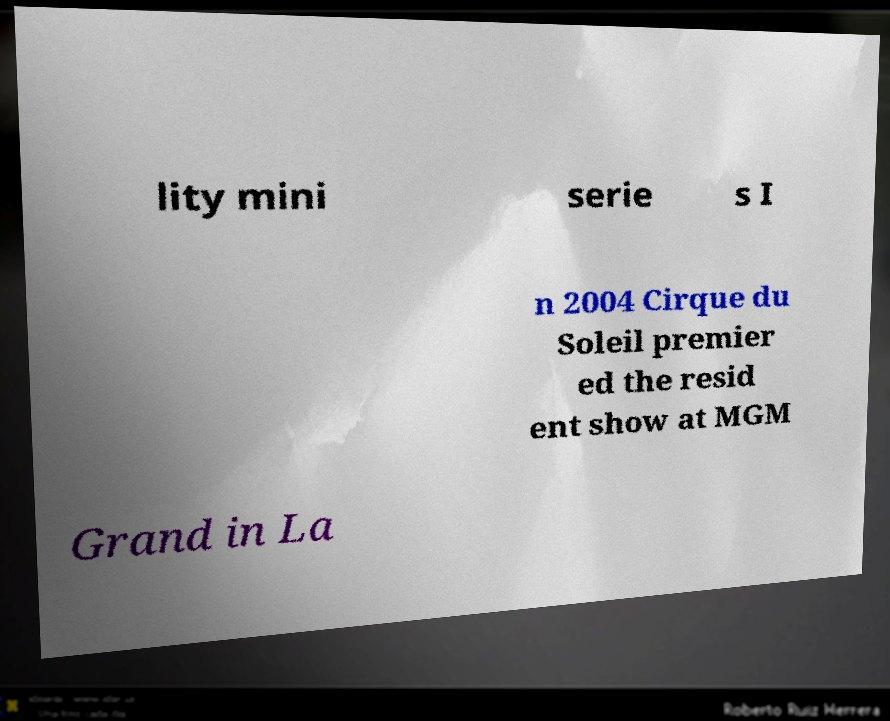Can you accurately transcribe the text from the provided image for me? lity mini serie s I n 2004 Cirque du Soleil premier ed the resid ent show at MGM Grand in La 